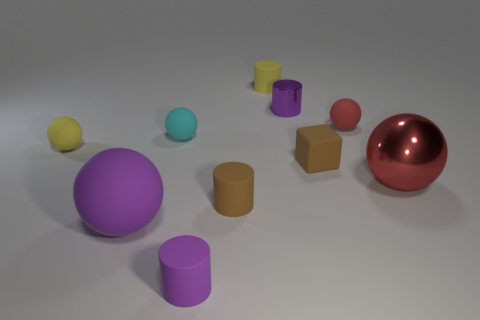Subtract all cylinders. How many objects are left? 6 Subtract all purple cylinders. How many cylinders are left? 2 Subtract all yellow balls. How many balls are left? 4 Subtract 5 spheres. How many spheres are left? 0 Subtract all small purple metallic objects. Subtract all small brown rubber cylinders. How many objects are left? 8 Add 5 large red shiny things. How many large red shiny things are left? 6 Add 5 big cylinders. How many big cylinders exist? 5 Subtract 0 blue spheres. How many objects are left? 10 Subtract all cyan blocks. Subtract all red cylinders. How many blocks are left? 1 Subtract all purple cubes. How many green spheres are left? 0 